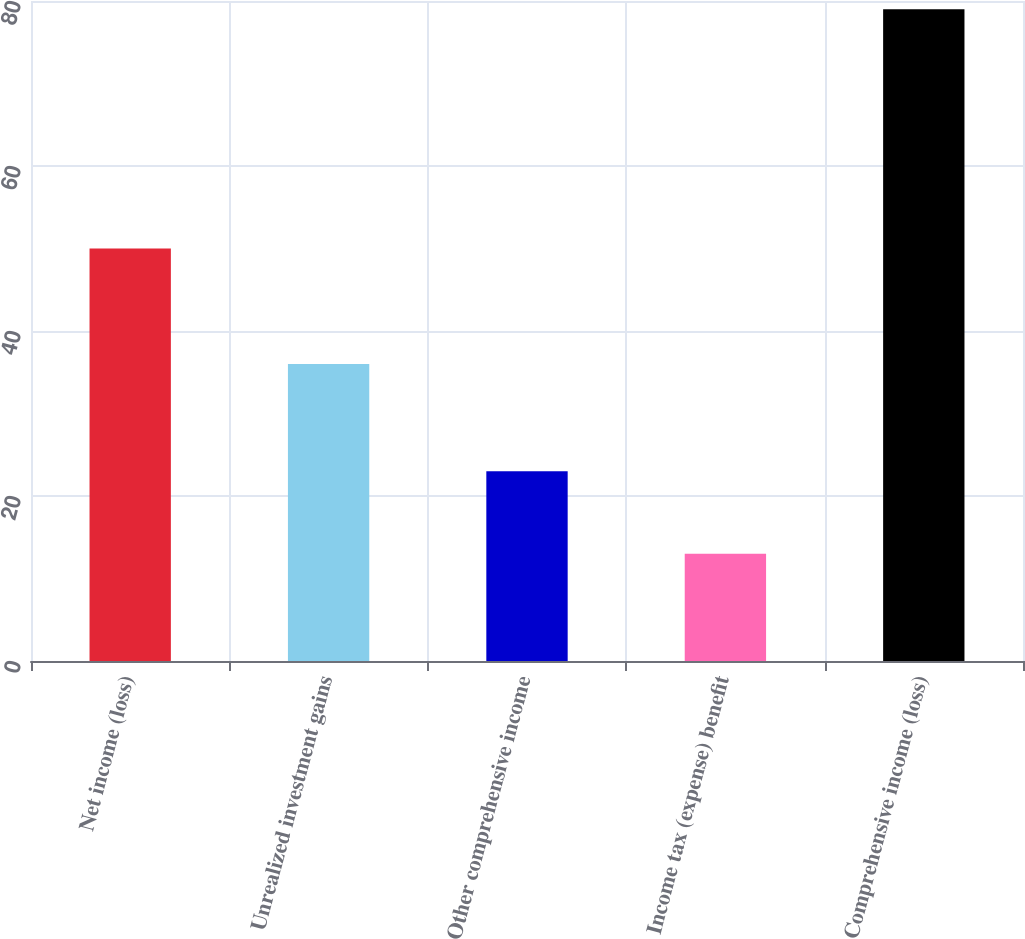Convert chart. <chart><loc_0><loc_0><loc_500><loc_500><bar_chart><fcel>Net income (loss)<fcel>Unrealized investment gains<fcel>Other comprehensive income<fcel>Income tax (expense) benefit<fcel>Comprehensive income (loss)<nl><fcel>50<fcel>36<fcel>23<fcel>13<fcel>79<nl></chart> 